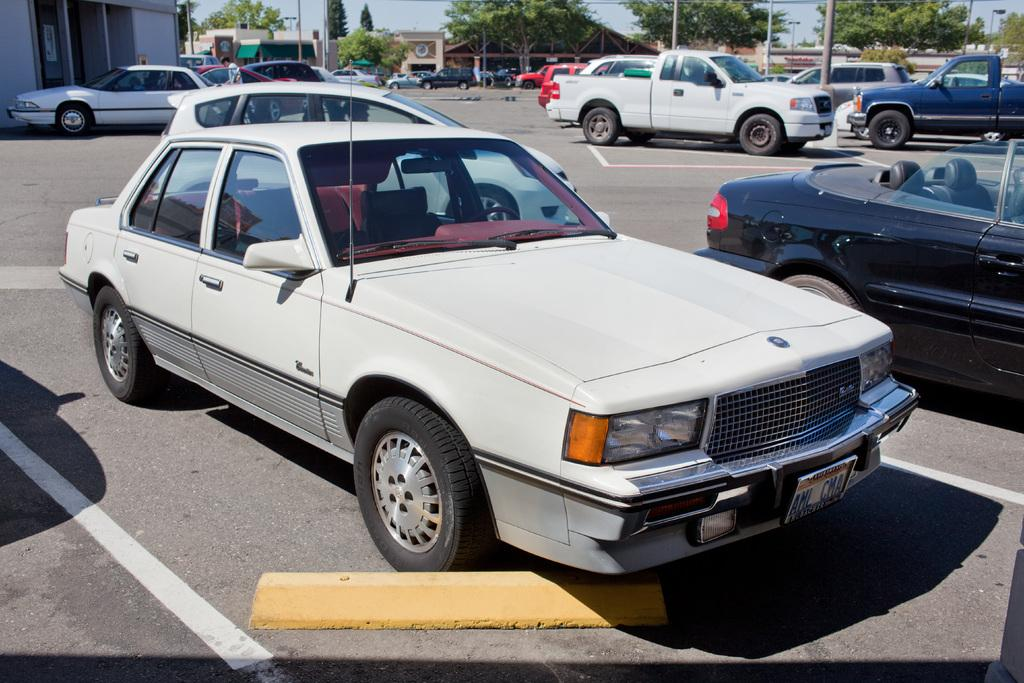What type of vehicle is in the image? There is a white car in the image. Where is the car located in the image? The car is parked on the road. Are there any other vehicles in the image? Yes, there are other vehicles parked on the road. What can be seen in the background of the image? Green trees are visible in the image. What type of lettuce is being used to promote peace in the image? There is no lettuce or promotion of peace present in the image. 